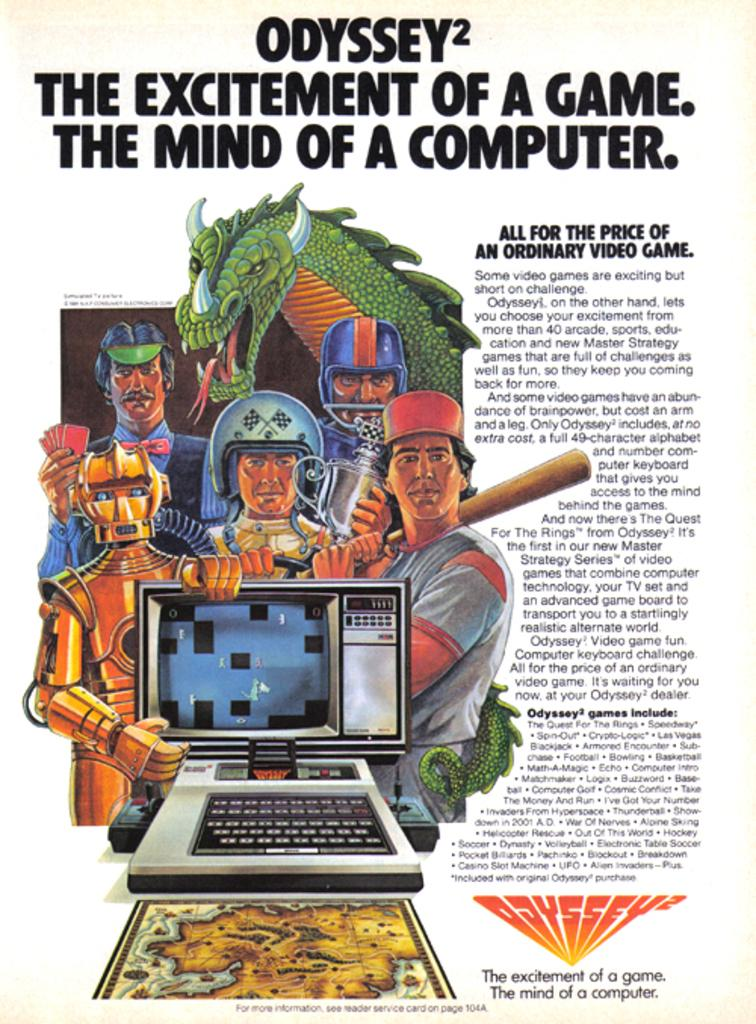<image>
Relay a brief, clear account of the picture shown. FLyer for a computer game, names Odyssey, the excitement of a game, the mind of a computer. 